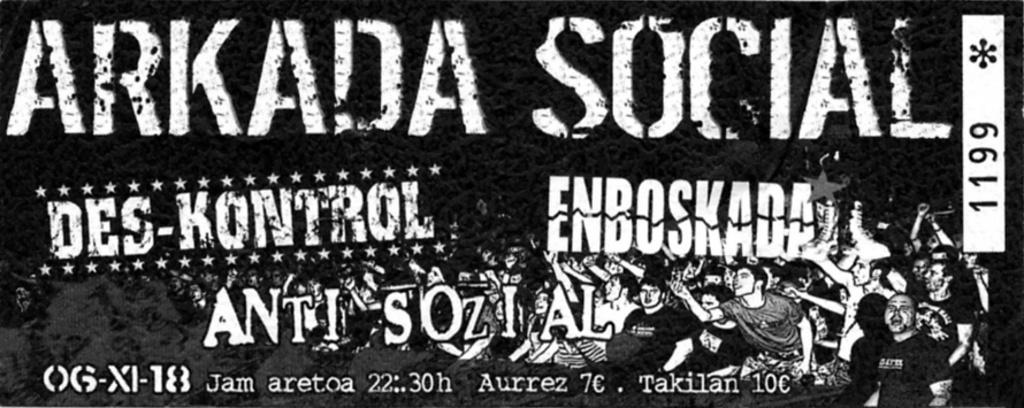What color is the text in the image? The text in the image is written in white color. What color is the background of the text? The background of the text is black. Can you see a neck in the image? There is no neck present in the image; it only contains text with a black background. 